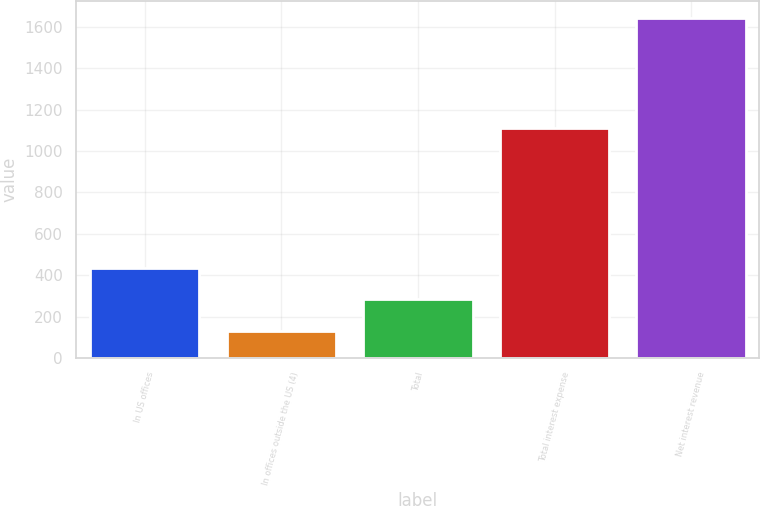<chart> <loc_0><loc_0><loc_500><loc_500><bar_chart><fcel>In US offices<fcel>In offices outside the US (4)<fcel>Total<fcel>Total interest expense<fcel>Net interest revenue<nl><fcel>433.8<fcel>131<fcel>282.4<fcel>1113<fcel>1645<nl></chart> 